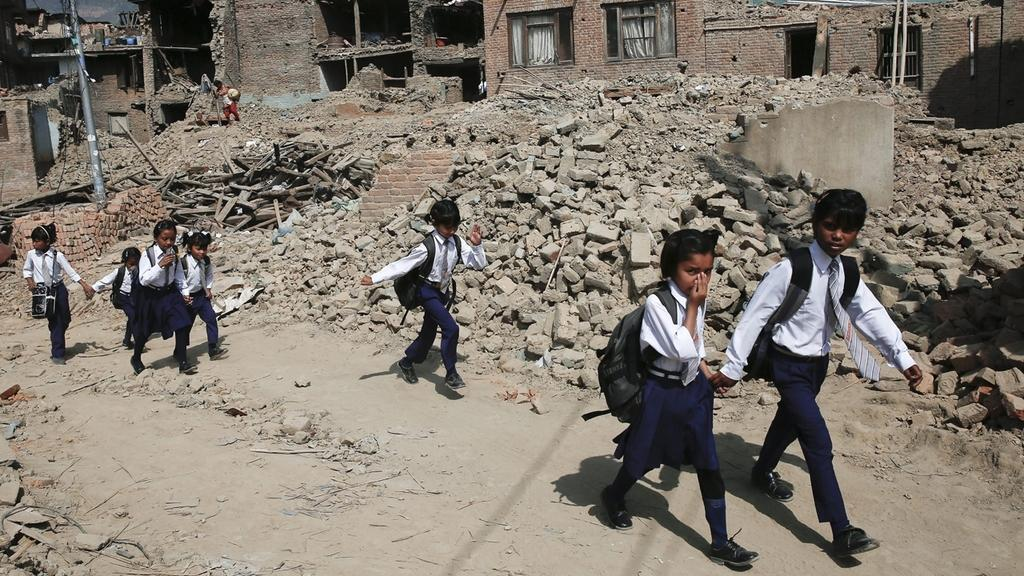Who is present in the image? There are children in the image. What are the children wearing? The children are wearing uniforms. What are the children doing in the image? The children are walking. What can be seen in the background of the image? There are buildings, bricks, poles, and logs in the background of the image. What type of tramp is visible in the image? There is no tramp present in the image. Can you tell me which brother is in the image? There is no reference to a brother or any specific individuals in the image. 